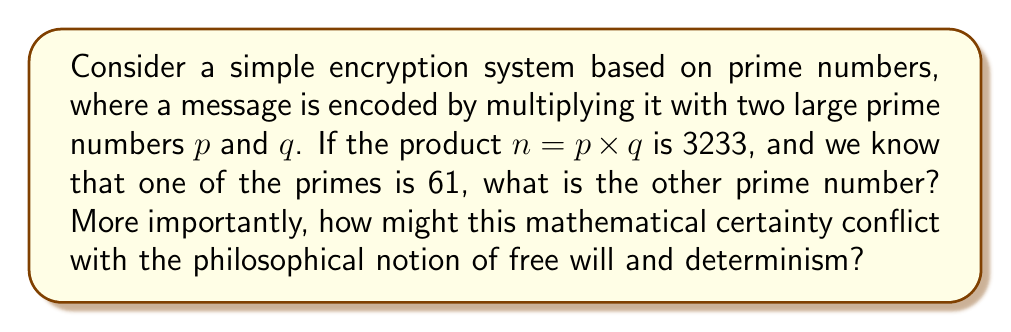Give your solution to this math problem. 1) First, let's solve the mathematical part:
   We know that $n = p \times q = 3233$ and one of the primes, let's say $p$, is 61.
   
   To find $q$, we simply divide $n$ by $p$:
   
   $q = \frac{n}{p} = \frac{3233}{61} = 53$

2) Now, let's consider the philosophical implications:

   a) Determinism: The fact that we can definitively calculate the other prime number suggests a form of mathematical determinism. Once the initial conditions (the product and one prime) are known, the outcome (the other prime) is inevitable.

   b) Predictability: This predictability in mathematics contrasts with the unpredictability often associated with free will in philosophy.

   c) Reductionism: The ability to break down the complex number into its prime factors might be seen as a form of reductionism, which some philosophers argue oversimplifies complex systems.

   d) Epistemology: The certainty of mathematical knowledge here contrasts with the often uncertain nature of philosophical knowledge.

   e) Nature of reality: The abstract nature of numbers and their concrete application in encryption raises questions about the relationship between abstract mathematical concepts and physical reality.

   f) Ethics: The use of this mathematical certainty for encryption, which can be used for both beneficial privacy and potentially harmful secrecy, raises ethical questions about the application of neutral mathematical concepts.

This tension between mathematical certainty and philosophical concepts of free will and determinism highlights the complex relationship between quantitative measures and qualitative concepts in understanding reality.
Answer: 53; Mathematical certainty conflicts with philosophical notions of free will and indeterminism. 